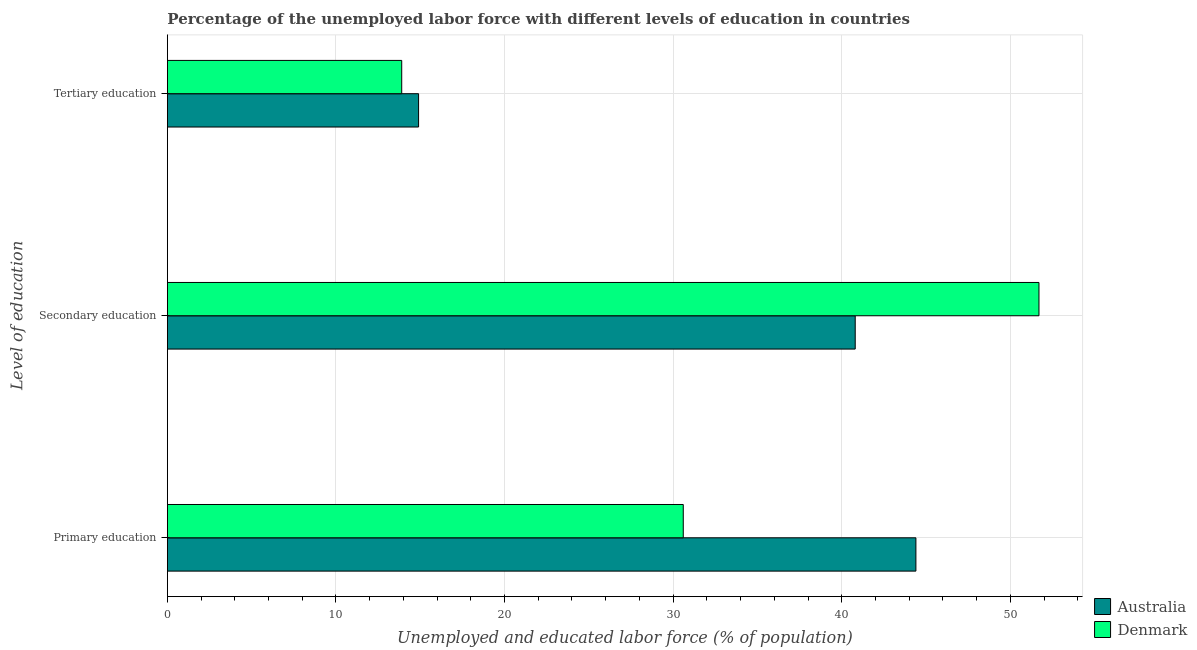How many different coloured bars are there?
Your answer should be very brief. 2. Are the number of bars per tick equal to the number of legend labels?
Keep it short and to the point. Yes. How many bars are there on the 1st tick from the bottom?
Keep it short and to the point. 2. What is the label of the 1st group of bars from the top?
Your answer should be compact. Tertiary education. What is the percentage of labor force who received primary education in Australia?
Provide a succinct answer. 44.4. Across all countries, what is the maximum percentage of labor force who received tertiary education?
Give a very brief answer. 14.9. Across all countries, what is the minimum percentage of labor force who received secondary education?
Give a very brief answer. 40.8. In which country was the percentage of labor force who received tertiary education maximum?
Offer a very short reply. Australia. What is the total percentage of labor force who received secondary education in the graph?
Your answer should be very brief. 92.5. What is the difference between the percentage of labor force who received primary education in Denmark and the percentage of labor force who received secondary education in Australia?
Your response must be concise. -10.2. What is the average percentage of labor force who received tertiary education per country?
Give a very brief answer. 14.4. What is the difference between the percentage of labor force who received tertiary education and percentage of labor force who received secondary education in Australia?
Provide a short and direct response. -25.9. What is the ratio of the percentage of labor force who received primary education in Australia to that in Denmark?
Your answer should be compact. 1.45. Is the percentage of labor force who received tertiary education in Australia less than that in Denmark?
Your answer should be very brief. No. What is the difference between the highest and the second highest percentage of labor force who received primary education?
Ensure brevity in your answer.  13.8. What is the difference between the highest and the lowest percentage of labor force who received tertiary education?
Ensure brevity in your answer.  1. In how many countries, is the percentage of labor force who received secondary education greater than the average percentage of labor force who received secondary education taken over all countries?
Provide a succinct answer. 1. Is the sum of the percentage of labor force who received primary education in Denmark and Australia greater than the maximum percentage of labor force who received tertiary education across all countries?
Keep it short and to the point. Yes. Is it the case that in every country, the sum of the percentage of labor force who received primary education and percentage of labor force who received secondary education is greater than the percentage of labor force who received tertiary education?
Provide a short and direct response. Yes. What is the difference between two consecutive major ticks on the X-axis?
Offer a terse response. 10. Are the values on the major ticks of X-axis written in scientific E-notation?
Keep it short and to the point. No. Does the graph contain any zero values?
Ensure brevity in your answer.  No. Does the graph contain grids?
Offer a very short reply. Yes. Where does the legend appear in the graph?
Offer a terse response. Bottom right. How many legend labels are there?
Give a very brief answer. 2. How are the legend labels stacked?
Your answer should be very brief. Vertical. What is the title of the graph?
Your answer should be compact. Percentage of the unemployed labor force with different levels of education in countries. Does "South Africa" appear as one of the legend labels in the graph?
Offer a very short reply. No. What is the label or title of the X-axis?
Make the answer very short. Unemployed and educated labor force (% of population). What is the label or title of the Y-axis?
Give a very brief answer. Level of education. What is the Unemployed and educated labor force (% of population) in Australia in Primary education?
Provide a short and direct response. 44.4. What is the Unemployed and educated labor force (% of population) of Denmark in Primary education?
Give a very brief answer. 30.6. What is the Unemployed and educated labor force (% of population) of Australia in Secondary education?
Ensure brevity in your answer.  40.8. What is the Unemployed and educated labor force (% of population) in Denmark in Secondary education?
Keep it short and to the point. 51.7. What is the Unemployed and educated labor force (% of population) of Australia in Tertiary education?
Provide a succinct answer. 14.9. What is the Unemployed and educated labor force (% of population) in Denmark in Tertiary education?
Your answer should be compact. 13.9. Across all Level of education, what is the maximum Unemployed and educated labor force (% of population) of Australia?
Offer a very short reply. 44.4. Across all Level of education, what is the maximum Unemployed and educated labor force (% of population) in Denmark?
Offer a very short reply. 51.7. Across all Level of education, what is the minimum Unemployed and educated labor force (% of population) in Australia?
Offer a very short reply. 14.9. Across all Level of education, what is the minimum Unemployed and educated labor force (% of population) in Denmark?
Provide a short and direct response. 13.9. What is the total Unemployed and educated labor force (% of population) of Australia in the graph?
Offer a terse response. 100.1. What is the total Unemployed and educated labor force (% of population) in Denmark in the graph?
Give a very brief answer. 96.2. What is the difference between the Unemployed and educated labor force (% of population) in Denmark in Primary education and that in Secondary education?
Keep it short and to the point. -21.1. What is the difference between the Unemployed and educated labor force (% of population) of Australia in Primary education and that in Tertiary education?
Your answer should be compact. 29.5. What is the difference between the Unemployed and educated labor force (% of population) of Australia in Secondary education and that in Tertiary education?
Your response must be concise. 25.9. What is the difference between the Unemployed and educated labor force (% of population) of Denmark in Secondary education and that in Tertiary education?
Give a very brief answer. 37.8. What is the difference between the Unemployed and educated labor force (% of population) in Australia in Primary education and the Unemployed and educated labor force (% of population) in Denmark in Tertiary education?
Your answer should be compact. 30.5. What is the difference between the Unemployed and educated labor force (% of population) in Australia in Secondary education and the Unemployed and educated labor force (% of population) in Denmark in Tertiary education?
Offer a very short reply. 26.9. What is the average Unemployed and educated labor force (% of population) in Australia per Level of education?
Your answer should be very brief. 33.37. What is the average Unemployed and educated labor force (% of population) in Denmark per Level of education?
Offer a terse response. 32.07. What is the difference between the Unemployed and educated labor force (% of population) of Australia and Unemployed and educated labor force (% of population) of Denmark in Secondary education?
Your answer should be compact. -10.9. What is the difference between the Unemployed and educated labor force (% of population) of Australia and Unemployed and educated labor force (% of population) of Denmark in Tertiary education?
Make the answer very short. 1. What is the ratio of the Unemployed and educated labor force (% of population) in Australia in Primary education to that in Secondary education?
Keep it short and to the point. 1.09. What is the ratio of the Unemployed and educated labor force (% of population) of Denmark in Primary education to that in Secondary education?
Your answer should be very brief. 0.59. What is the ratio of the Unemployed and educated labor force (% of population) in Australia in Primary education to that in Tertiary education?
Ensure brevity in your answer.  2.98. What is the ratio of the Unemployed and educated labor force (% of population) of Denmark in Primary education to that in Tertiary education?
Keep it short and to the point. 2.2. What is the ratio of the Unemployed and educated labor force (% of population) in Australia in Secondary education to that in Tertiary education?
Keep it short and to the point. 2.74. What is the ratio of the Unemployed and educated labor force (% of population) of Denmark in Secondary education to that in Tertiary education?
Make the answer very short. 3.72. What is the difference between the highest and the second highest Unemployed and educated labor force (% of population) of Australia?
Offer a very short reply. 3.6. What is the difference between the highest and the second highest Unemployed and educated labor force (% of population) in Denmark?
Give a very brief answer. 21.1. What is the difference between the highest and the lowest Unemployed and educated labor force (% of population) in Australia?
Keep it short and to the point. 29.5. What is the difference between the highest and the lowest Unemployed and educated labor force (% of population) of Denmark?
Ensure brevity in your answer.  37.8. 